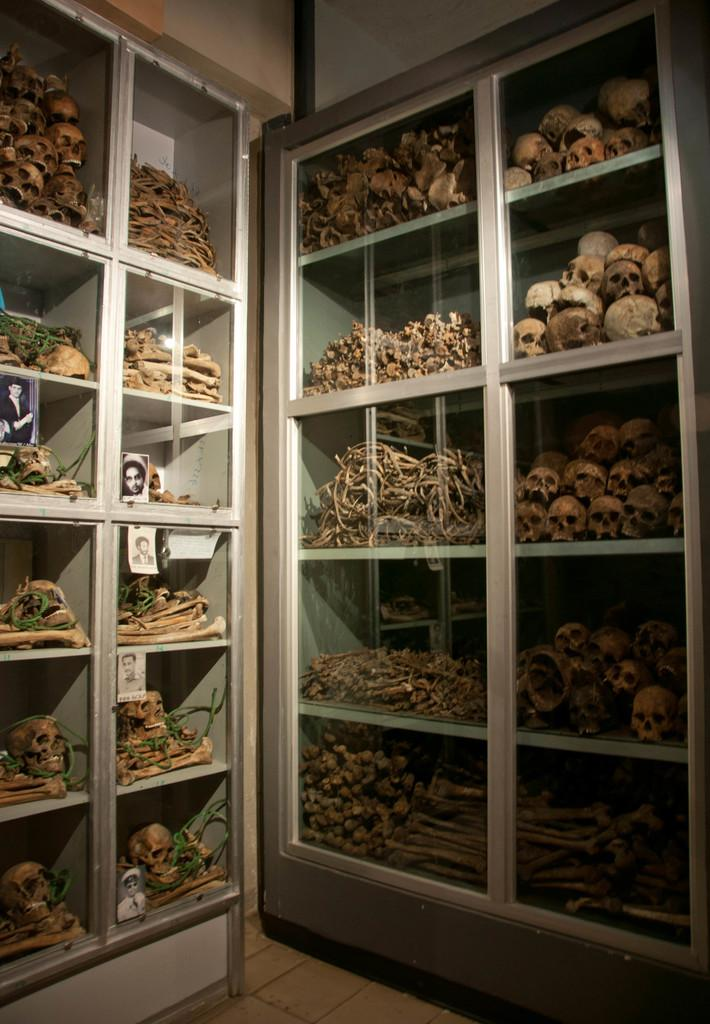What type of shells are depicted in the image? The shells of human body are depicted in the image. Where are these shells located? The shells are placed in cupboards. How many ants can be seen crawling on the shells in the image? There are no ants present in the image; it only shows shells of human body placed in cupboards. 